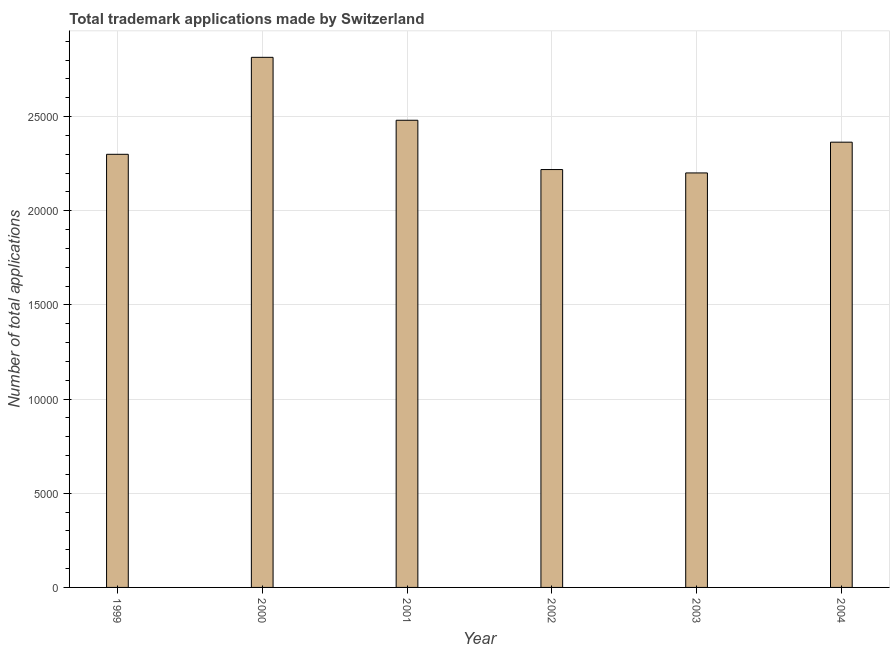What is the title of the graph?
Give a very brief answer. Total trademark applications made by Switzerland. What is the label or title of the X-axis?
Provide a short and direct response. Year. What is the label or title of the Y-axis?
Your response must be concise. Number of total applications. What is the number of trademark applications in 2000?
Provide a succinct answer. 2.81e+04. Across all years, what is the maximum number of trademark applications?
Provide a short and direct response. 2.81e+04. Across all years, what is the minimum number of trademark applications?
Your response must be concise. 2.20e+04. In which year was the number of trademark applications maximum?
Provide a short and direct response. 2000. What is the sum of the number of trademark applications?
Your answer should be compact. 1.44e+05. What is the difference between the number of trademark applications in 2001 and 2002?
Offer a terse response. 2618. What is the average number of trademark applications per year?
Provide a succinct answer. 2.40e+04. What is the median number of trademark applications?
Your answer should be very brief. 2.33e+04. What is the ratio of the number of trademark applications in 2003 to that in 2004?
Offer a terse response. 0.93. Is the number of trademark applications in 1999 less than that in 2003?
Give a very brief answer. No. Is the difference between the number of trademark applications in 2003 and 2004 greater than the difference between any two years?
Make the answer very short. No. What is the difference between the highest and the second highest number of trademark applications?
Provide a short and direct response. 3341. Is the sum of the number of trademark applications in 2001 and 2002 greater than the maximum number of trademark applications across all years?
Give a very brief answer. Yes. What is the difference between the highest and the lowest number of trademark applications?
Ensure brevity in your answer.  6138. How many bars are there?
Give a very brief answer. 6. Are all the bars in the graph horizontal?
Your answer should be compact. No. What is the difference between two consecutive major ticks on the Y-axis?
Your response must be concise. 5000. Are the values on the major ticks of Y-axis written in scientific E-notation?
Provide a short and direct response. No. What is the Number of total applications of 1999?
Give a very brief answer. 2.30e+04. What is the Number of total applications of 2000?
Offer a very short reply. 2.81e+04. What is the Number of total applications of 2001?
Keep it short and to the point. 2.48e+04. What is the Number of total applications in 2002?
Offer a terse response. 2.22e+04. What is the Number of total applications of 2003?
Your response must be concise. 2.20e+04. What is the Number of total applications in 2004?
Your response must be concise. 2.36e+04. What is the difference between the Number of total applications in 1999 and 2000?
Your answer should be very brief. -5149. What is the difference between the Number of total applications in 1999 and 2001?
Provide a succinct answer. -1808. What is the difference between the Number of total applications in 1999 and 2002?
Your response must be concise. 810. What is the difference between the Number of total applications in 1999 and 2003?
Your answer should be very brief. 989. What is the difference between the Number of total applications in 1999 and 2004?
Give a very brief answer. -644. What is the difference between the Number of total applications in 2000 and 2001?
Your answer should be compact. 3341. What is the difference between the Number of total applications in 2000 and 2002?
Offer a terse response. 5959. What is the difference between the Number of total applications in 2000 and 2003?
Ensure brevity in your answer.  6138. What is the difference between the Number of total applications in 2000 and 2004?
Your answer should be compact. 4505. What is the difference between the Number of total applications in 2001 and 2002?
Ensure brevity in your answer.  2618. What is the difference between the Number of total applications in 2001 and 2003?
Give a very brief answer. 2797. What is the difference between the Number of total applications in 2001 and 2004?
Make the answer very short. 1164. What is the difference between the Number of total applications in 2002 and 2003?
Provide a succinct answer. 179. What is the difference between the Number of total applications in 2002 and 2004?
Your response must be concise. -1454. What is the difference between the Number of total applications in 2003 and 2004?
Ensure brevity in your answer.  -1633. What is the ratio of the Number of total applications in 1999 to that in 2000?
Give a very brief answer. 0.82. What is the ratio of the Number of total applications in 1999 to that in 2001?
Your response must be concise. 0.93. What is the ratio of the Number of total applications in 1999 to that in 2003?
Provide a short and direct response. 1.04. What is the ratio of the Number of total applications in 1999 to that in 2004?
Provide a short and direct response. 0.97. What is the ratio of the Number of total applications in 2000 to that in 2001?
Offer a terse response. 1.14. What is the ratio of the Number of total applications in 2000 to that in 2002?
Your answer should be very brief. 1.27. What is the ratio of the Number of total applications in 2000 to that in 2003?
Make the answer very short. 1.28. What is the ratio of the Number of total applications in 2000 to that in 2004?
Your answer should be compact. 1.19. What is the ratio of the Number of total applications in 2001 to that in 2002?
Your answer should be very brief. 1.12. What is the ratio of the Number of total applications in 2001 to that in 2003?
Your answer should be very brief. 1.13. What is the ratio of the Number of total applications in 2001 to that in 2004?
Offer a very short reply. 1.05. What is the ratio of the Number of total applications in 2002 to that in 2003?
Your answer should be very brief. 1.01. What is the ratio of the Number of total applications in 2002 to that in 2004?
Your answer should be compact. 0.94. 